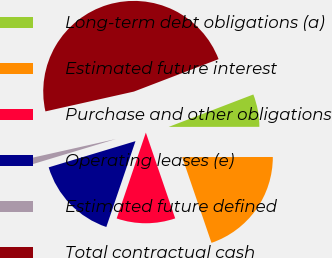Convert chart to OTSL. <chart><loc_0><loc_0><loc_500><loc_500><pie_chart><fcel>Long-term debt obligations (a)<fcel>Estimated future interest<fcel>Purchase and other obligations<fcel>Operating leases (e)<fcel>Estimated future defined<fcel>Total contractual cash<nl><fcel>5.81%<fcel>19.77%<fcel>10.46%<fcel>15.12%<fcel>1.16%<fcel>47.69%<nl></chart> 